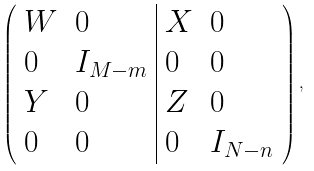<formula> <loc_0><loc_0><loc_500><loc_500>\left ( \begin{array} { l l | l l } W & 0 & X & 0 \\ 0 & I _ { M - m } & 0 & 0 \\ Y & 0 & Z & 0 \\ 0 & 0 & 0 & I _ { N - n } \end{array} \right ) ,</formula> 